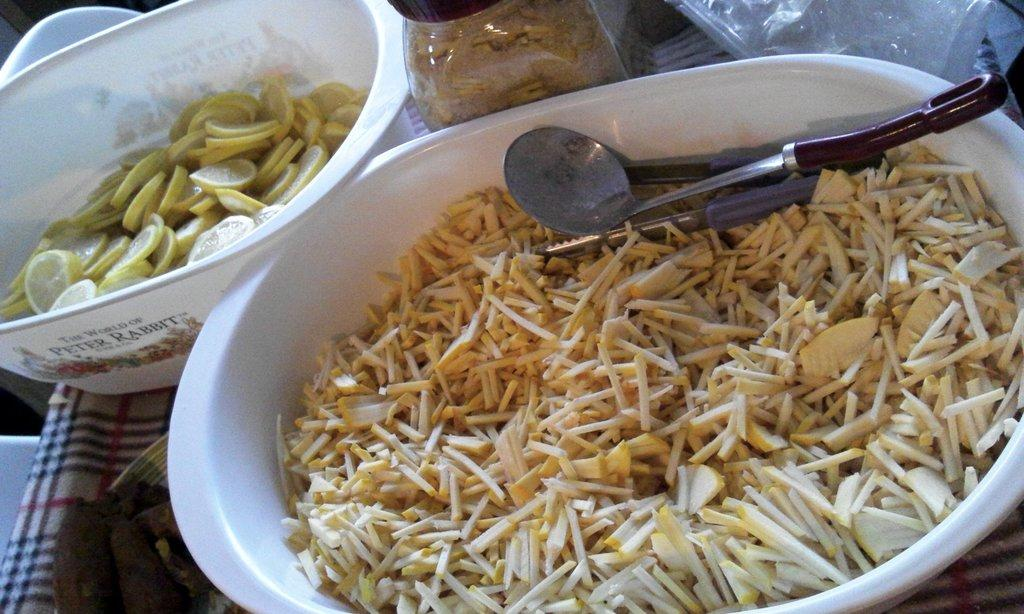What type of containers are present in the image? There are bowls in the image. What else can be seen in the image besides the bowls? There is cutlery and a jar in the image. What is inside the containers? There is food in the bowls and the jar. Are there any words or markings on the bowls? Yes, there is text on the bowls. How does the van help with the food preparation in the image? There is no van present in the image, so it cannot help with food preparation. 